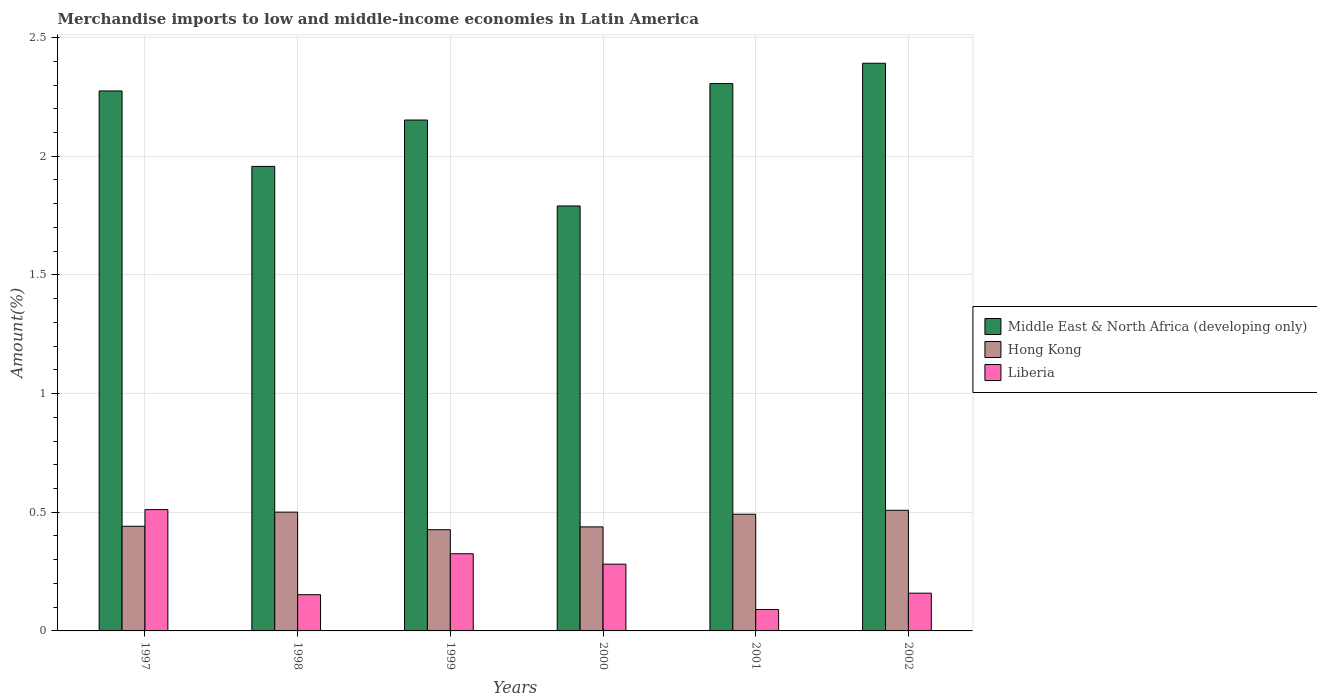Are the number of bars per tick equal to the number of legend labels?
Give a very brief answer. Yes. Are the number of bars on each tick of the X-axis equal?
Your response must be concise. Yes. How many bars are there on the 5th tick from the left?
Give a very brief answer. 3. How many bars are there on the 1st tick from the right?
Offer a terse response. 3. What is the percentage of amount earned from merchandise imports in Liberia in 2001?
Your response must be concise. 0.09. Across all years, what is the maximum percentage of amount earned from merchandise imports in Liberia?
Keep it short and to the point. 0.51. Across all years, what is the minimum percentage of amount earned from merchandise imports in Middle East & North Africa (developing only)?
Keep it short and to the point. 1.79. What is the total percentage of amount earned from merchandise imports in Middle East & North Africa (developing only) in the graph?
Offer a very short reply. 12.87. What is the difference between the percentage of amount earned from merchandise imports in Hong Kong in 2000 and that in 2001?
Your answer should be very brief. -0.05. What is the difference between the percentage of amount earned from merchandise imports in Middle East & North Africa (developing only) in 2002 and the percentage of amount earned from merchandise imports in Liberia in 1999?
Make the answer very short. 2.07. What is the average percentage of amount earned from merchandise imports in Liberia per year?
Offer a terse response. 0.25. In the year 2000, what is the difference between the percentage of amount earned from merchandise imports in Liberia and percentage of amount earned from merchandise imports in Middle East & North Africa (developing only)?
Give a very brief answer. -1.51. What is the ratio of the percentage of amount earned from merchandise imports in Hong Kong in 1997 to that in 1999?
Provide a short and direct response. 1.03. Is the percentage of amount earned from merchandise imports in Hong Kong in 1998 less than that in 2002?
Offer a terse response. Yes. What is the difference between the highest and the second highest percentage of amount earned from merchandise imports in Hong Kong?
Offer a terse response. 0.01. What is the difference between the highest and the lowest percentage of amount earned from merchandise imports in Middle East & North Africa (developing only)?
Your answer should be compact. 0.6. What does the 2nd bar from the left in 2001 represents?
Your response must be concise. Hong Kong. What does the 2nd bar from the right in 1997 represents?
Your answer should be compact. Hong Kong. Is it the case that in every year, the sum of the percentage of amount earned from merchandise imports in Middle East & North Africa (developing only) and percentage of amount earned from merchandise imports in Hong Kong is greater than the percentage of amount earned from merchandise imports in Liberia?
Your answer should be very brief. Yes. How many bars are there?
Make the answer very short. 18. Does the graph contain grids?
Provide a short and direct response. Yes. Where does the legend appear in the graph?
Offer a very short reply. Center right. How many legend labels are there?
Give a very brief answer. 3. What is the title of the graph?
Give a very brief answer. Merchandise imports to low and middle-income economies in Latin America. Does "Liechtenstein" appear as one of the legend labels in the graph?
Offer a very short reply. No. What is the label or title of the Y-axis?
Your response must be concise. Amount(%). What is the Amount(%) of Middle East & North Africa (developing only) in 1997?
Provide a short and direct response. 2.28. What is the Amount(%) of Hong Kong in 1997?
Provide a short and direct response. 0.44. What is the Amount(%) of Liberia in 1997?
Keep it short and to the point. 0.51. What is the Amount(%) of Middle East & North Africa (developing only) in 1998?
Keep it short and to the point. 1.96. What is the Amount(%) of Hong Kong in 1998?
Your answer should be very brief. 0.5. What is the Amount(%) of Liberia in 1998?
Give a very brief answer. 0.15. What is the Amount(%) in Middle East & North Africa (developing only) in 1999?
Give a very brief answer. 2.15. What is the Amount(%) of Hong Kong in 1999?
Provide a succinct answer. 0.43. What is the Amount(%) in Liberia in 1999?
Give a very brief answer. 0.33. What is the Amount(%) in Middle East & North Africa (developing only) in 2000?
Your response must be concise. 1.79. What is the Amount(%) of Hong Kong in 2000?
Offer a terse response. 0.44. What is the Amount(%) in Liberia in 2000?
Give a very brief answer. 0.28. What is the Amount(%) in Middle East & North Africa (developing only) in 2001?
Offer a very short reply. 2.31. What is the Amount(%) in Hong Kong in 2001?
Keep it short and to the point. 0.49. What is the Amount(%) of Liberia in 2001?
Give a very brief answer. 0.09. What is the Amount(%) of Middle East & North Africa (developing only) in 2002?
Ensure brevity in your answer.  2.39. What is the Amount(%) in Hong Kong in 2002?
Provide a succinct answer. 0.51. What is the Amount(%) of Liberia in 2002?
Provide a succinct answer. 0.16. Across all years, what is the maximum Amount(%) of Middle East & North Africa (developing only)?
Your response must be concise. 2.39. Across all years, what is the maximum Amount(%) of Hong Kong?
Give a very brief answer. 0.51. Across all years, what is the maximum Amount(%) of Liberia?
Offer a very short reply. 0.51. Across all years, what is the minimum Amount(%) of Middle East & North Africa (developing only)?
Ensure brevity in your answer.  1.79. Across all years, what is the minimum Amount(%) of Hong Kong?
Your response must be concise. 0.43. Across all years, what is the minimum Amount(%) of Liberia?
Make the answer very short. 0.09. What is the total Amount(%) of Middle East & North Africa (developing only) in the graph?
Offer a very short reply. 12.87. What is the total Amount(%) of Hong Kong in the graph?
Your response must be concise. 2.81. What is the total Amount(%) of Liberia in the graph?
Ensure brevity in your answer.  1.52. What is the difference between the Amount(%) in Middle East & North Africa (developing only) in 1997 and that in 1998?
Your answer should be compact. 0.32. What is the difference between the Amount(%) of Hong Kong in 1997 and that in 1998?
Make the answer very short. -0.06. What is the difference between the Amount(%) of Liberia in 1997 and that in 1998?
Offer a terse response. 0.36. What is the difference between the Amount(%) in Middle East & North Africa (developing only) in 1997 and that in 1999?
Ensure brevity in your answer.  0.12. What is the difference between the Amount(%) of Hong Kong in 1997 and that in 1999?
Provide a succinct answer. 0.01. What is the difference between the Amount(%) in Liberia in 1997 and that in 1999?
Offer a very short reply. 0.19. What is the difference between the Amount(%) in Middle East & North Africa (developing only) in 1997 and that in 2000?
Offer a very short reply. 0.48. What is the difference between the Amount(%) of Hong Kong in 1997 and that in 2000?
Your answer should be compact. 0. What is the difference between the Amount(%) of Liberia in 1997 and that in 2000?
Your response must be concise. 0.23. What is the difference between the Amount(%) of Middle East & North Africa (developing only) in 1997 and that in 2001?
Keep it short and to the point. -0.03. What is the difference between the Amount(%) in Hong Kong in 1997 and that in 2001?
Offer a very short reply. -0.05. What is the difference between the Amount(%) in Liberia in 1997 and that in 2001?
Your answer should be very brief. 0.42. What is the difference between the Amount(%) in Middle East & North Africa (developing only) in 1997 and that in 2002?
Your response must be concise. -0.12. What is the difference between the Amount(%) of Hong Kong in 1997 and that in 2002?
Your answer should be compact. -0.07. What is the difference between the Amount(%) in Liberia in 1997 and that in 2002?
Give a very brief answer. 0.35. What is the difference between the Amount(%) of Middle East & North Africa (developing only) in 1998 and that in 1999?
Give a very brief answer. -0.2. What is the difference between the Amount(%) in Hong Kong in 1998 and that in 1999?
Give a very brief answer. 0.07. What is the difference between the Amount(%) of Liberia in 1998 and that in 1999?
Make the answer very short. -0.17. What is the difference between the Amount(%) in Middle East & North Africa (developing only) in 1998 and that in 2000?
Your answer should be very brief. 0.17. What is the difference between the Amount(%) in Hong Kong in 1998 and that in 2000?
Your answer should be very brief. 0.06. What is the difference between the Amount(%) of Liberia in 1998 and that in 2000?
Your answer should be compact. -0.13. What is the difference between the Amount(%) of Middle East & North Africa (developing only) in 1998 and that in 2001?
Offer a terse response. -0.35. What is the difference between the Amount(%) of Hong Kong in 1998 and that in 2001?
Give a very brief answer. 0.01. What is the difference between the Amount(%) of Liberia in 1998 and that in 2001?
Keep it short and to the point. 0.06. What is the difference between the Amount(%) in Middle East & North Africa (developing only) in 1998 and that in 2002?
Offer a terse response. -0.43. What is the difference between the Amount(%) of Hong Kong in 1998 and that in 2002?
Make the answer very short. -0.01. What is the difference between the Amount(%) of Liberia in 1998 and that in 2002?
Make the answer very short. -0.01. What is the difference between the Amount(%) in Middle East & North Africa (developing only) in 1999 and that in 2000?
Provide a succinct answer. 0.36. What is the difference between the Amount(%) of Hong Kong in 1999 and that in 2000?
Provide a short and direct response. -0.01. What is the difference between the Amount(%) of Liberia in 1999 and that in 2000?
Make the answer very short. 0.04. What is the difference between the Amount(%) of Middle East & North Africa (developing only) in 1999 and that in 2001?
Your answer should be compact. -0.15. What is the difference between the Amount(%) in Hong Kong in 1999 and that in 2001?
Make the answer very short. -0.07. What is the difference between the Amount(%) of Liberia in 1999 and that in 2001?
Keep it short and to the point. 0.23. What is the difference between the Amount(%) of Middle East & North Africa (developing only) in 1999 and that in 2002?
Your answer should be compact. -0.24. What is the difference between the Amount(%) of Hong Kong in 1999 and that in 2002?
Offer a terse response. -0.08. What is the difference between the Amount(%) of Liberia in 1999 and that in 2002?
Your response must be concise. 0.17. What is the difference between the Amount(%) of Middle East & North Africa (developing only) in 2000 and that in 2001?
Your answer should be very brief. -0.52. What is the difference between the Amount(%) in Hong Kong in 2000 and that in 2001?
Ensure brevity in your answer.  -0.05. What is the difference between the Amount(%) in Liberia in 2000 and that in 2001?
Your response must be concise. 0.19. What is the difference between the Amount(%) in Middle East & North Africa (developing only) in 2000 and that in 2002?
Your response must be concise. -0.6. What is the difference between the Amount(%) of Hong Kong in 2000 and that in 2002?
Offer a terse response. -0.07. What is the difference between the Amount(%) of Liberia in 2000 and that in 2002?
Keep it short and to the point. 0.12. What is the difference between the Amount(%) of Middle East & North Africa (developing only) in 2001 and that in 2002?
Provide a succinct answer. -0.09. What is the difference between the Amount(%) in Hong Kong in 2001 and that in 2002?
Make the answer very short. -0.02. What is the difference between the Amount(%) of Liberia in 2001 and that in 2002?
Keep it short and to the point. -0.07. What is the difference between the Amount(%) of Middle East & North Africa (developing only) in 1997 and the Amount(%) of Hong Kong in 1998?
Provide a short and direct response. 1.77. What is the difference between the Amount(%) in Middle East & North Africa (developing only) in 1997 and the Amount(%) in Liberia in 1998?
Ensure brevity in your answer.  2.12. What is the difference between the Amount(%) in Hong Kong in 1997 and the Amount(%) in Liberia in 1998?
Offer a terse response. 0.29. What is the difference between the Amount(%) in Middle East & North Africa (developing only) in 1997 and the Amount(%) in Hong Kong in 1999?
Provide a succinct answer. 1.85. What is the difference between the Amount(%) of Middle East & North Africa (developing only) in 1997 and the Amount(%) of Liberia in 1999?
Your answer should be very brief. 1.95. What is the difference between the Amount(%) in Hong Kong in 1997 and the Amount(%) in Liberia in 1999?
Provide a succinct answer. 0.12. What is the difference between the Amount(%) of Middle East & North Africa (developing only) in 1997 and the Amount(%) of Hong Kong in 2000?
Keep it short and to the point. 1.84. What is the difference between the Amount(%) of Middle East & North Africa (developing only) in 1997 and the Amount(%) of Liberia in 2000?
Keep it short and to the point. 1.99. What is the difference between the Amount(%) in Hong Kong in 1997 and the Amount(%) in Liberia in 2000?
Offer a terse response. 0.16. What is the difference between the Amount(%) in Middle East & North Africa (developing only) in 1997 and the Amount(%) in Hong Kong in 2001?
Your response must be concise. 1.78. What is the difference between the Amount(%) in Middle East & North Africa (developing only) in 1997 and the Amount(%) in Liberia in 2001?
Offer a terse response. 2.18. What is the difference between the Amount(%) of Hong Kong in 1997 and the Amount(%) of Liberia in 2001?
Provide a short and direct response. 0.35. What is the difference between the Amount(%) of Middle East & North Africa (developing only) in 1997 and the Amount(%) of Hong Kong in 2002?
Offer a terse response. 1.77. What is the difference between the Amount(%) in Middle East & North Africa (developing only) in 1997 and the Amount(%) in Liberia in 2002?
Offer a terse response. 2.12. What is the difference between the Amount(%) in Hong Kong in 1997 and the Amount(%) in Liberia in 2002?
Make the answer very short. 0.28. What is the difference between the Amount(%) of Middle East & North Africa (developing only) in 1998 and the Amount(%) of Hong Kong in 1999?
Offer a very short reply. 1.53. What is the difference between the Amount(%) of Middle East & North Africa (developing only) in 1998 and the Amount(%) of Liberia in 1999?
Offer a very short reply. 1.63. What is the difference between the Amount(%) of Hong Kong in 1998 and the Amount(%) of Liberia in 1999?
Your answer should be very brief. 0.18. What is the difference between the Amount(%) of Middle East & North Africa (developing only) in 1998 and the Amount(%) of Hong Kong in 2000?
Your answer should be compact. 1.52. What is the difference between the Amount(%) in Middle East & North Africa (developing only) in 1998 and the Amount(%) in Liberia in 2000?
Provide a succinct answer. 1.68. What is the difference between the Amount(%) in Hong Kong in 1998 and the Amount(%) in Liberia in 2000?
Your response must be concise. 0.22. What is the difference between the Amount(%) in Middle East & North Africa (developing only) in 1998 and the Amount(%) in Hong Kong in 2001?
Provide a short and direct response. 1.47. What is the difference between the Amount(%) of Middle East & North Africa (developing only) in 1998 and the Amount(%) of Liberia in 2001?
Your response must be concise. 1.87. What is the difference between the Amount(%) of Hong Kong in 1998 and the Amount(%) of Liberia in 2001?
Offer a very short reply. 0.41. What is the difference between the Amount(%) in Middle East & North Africa (developing only) in 1998 and the Amount(%) in Hong Kong in 2002?
Give a very brief answer. 1.45. What is the difference between the Amount(%) of Middle East & North Africa (developing only) in 1998 and the Amount(%) of Liberia in 2002?
Ensure brevity in your answer.  1.8. What is the difference between the Amount(%) of Hong Kong in 1998 and the Amount(%) of Liberia in 2002?
Give a very brief answer. 0.34. What is the difference between the Amount(%) in Middle East & North Africa (developing only) in 1999 and the Amount(%) in Hong Kong in 2000?
Provide a succinct answer. 1.71. What is the difference between the Amount(%) of Middle East & North Africa (developing only) in 1999 and the Amount(%) of Liberia in 2000?
Your response must be concise. 1.87. What is the difference between the Amount(%) in Hong Kong in 1999 and the Amount(%) in Liberia in 2000?
Offer a very short reply. 0.15. What is the difference between the Amount(%) in Middle East & North Africa (developing only) in 1999 and the Amount(%) in Hong Kong in 2001?
Your answer should be very brief. 1.66. What is the difference between the Amount(%) of Middle East & North Africa (developing only) in 1999 and the Amount(%) of Liberia in 2001?
Your response must be concise. 2.06. What is the difference between the Amount(%) of Hong Kong in 1999 and the Amount(%) of Liberia in 2001?
Your answer should be very brief. 0.34. What is the difference between the Amount(%) of Middle East & North Africa (developing only) in 1999 and the Amount(%) of Hong Kong in 2002?
Make the answer very short. 1.64. What is the difference between the Amount(%) of Middle East & North Africa (developing only) in 1999 and the Amount(%) of Liberia in 2002?
Your response must be concise. 1.99. What is the difference between the Amount(%) in Hong Kong in 1999 and the Amount(%) in Liberia in 2002?
Your answer should be very brief. 0.27. What is the difference between the Amount(%) in Middle East & North Africa (developing only) in 2000 and the Amount(%) in Hong Kong in 2001?
Keep it short and to the point. 1.3. What is the difference between the Amount(%) in Middle East & North Africa (developing only) in 2000 and the Amount(%) in Liberia in 2001?
Give a very brief answer. 1.7. What is the difference between the Amount(%) in Hong Kong in 2000 and the Amount(%) in Liberia in 2001?
Offer a very short reply. 0.35. What is the difference between the Amount(%) in Middle East & North Africa (developing only) in 2000 and the Amount(%) in Hong Kong in 2002?
Offer a very short reply. 1.28. What is the difference between the Amount(%) in Middle East & North Africa (developing only) in 2000 and the Amount(%) in Liberia in 2002?
Offer a very short reply. 1.63. What is the difference between the Amount(%) of Hong Kong in 2000 and the Amount(%) of Liberia in 2002?
Provide a short and direct response. 0.28. What is the difference between the Amount(%) of Middle East & North Africa (developing only) in 2001 and the Amount(%) of Hong Kong in 2002?
Ensure brevity in your answer.  1.8. What is the difference between the Amount(%) in Middle East & North Africa (developing only) in 2001 and the Amount(%) in Liberia in 2002?
Your answer should be very brief. 2.15. What is the difference between the Amount(%) in Hong Kong in 2001 and the Amount(%) in Liberia in 2002?
Keep it short and to the point. 0.33. What is the average Amount(%) of Middle East & North Africa (developing only) per year?
Your answer should be compact. 2.15. What is the average Amount(%) in Hong Kong per year?
Keep it short and to the point. 0.47. What is the average Amount(%) in Liberia per year?
Give a very brief answer. 0.25. In the year 1997, what is the difference between the Amount(%) in Middle East & North Africa (developing only) and Amount(%) in Hong Kong?
Your response must be concise. 1.83. In the year 1997, what is the difference between the Amount(%) in Middle East & North Africa (developing only) and Amount(%) in Liberia?
Keep it short and to the point. 1.76. In the year 1997, what is the difference between the Amount(%) of Hong Kong and Amount(%) of Liberia?
Make the answer very short. -0.07. In the year 1998, what is the difference between the Amount(%) in Middle East & North Africa (developing only) and Amount(%) in Hong Kong?
Make the answer very short. 1.46. In the year 1998, what is the difference between the Amount(%) in Middle East & North Africa (developing only) and Amount(%) in Liberia?
Give a very brief answer. 1.8. In the year 1998, what is the difference between the Amount(%) of Hong Kong and Amount(%) of Liberia?
Provide a succinct answer. 0.35. In the year 1999, what is the difference between the Amount(%) of Middle East & North Africa (developing only) and Amount(%) of Hong Kong?
Offer a very short reply. 1.73. In the year 1999, what is the difference between the Amount(%) in Middle East & North Africa (developing only) and Amount(%) in Liberia?
Give a very brief answer. 1.83. In the year 1999, what is the difference between the Amount(%) of Hong Kong and Amount(%) of Liberia?
Offer a terse response. 0.1. In the year 2000, what is the difference between the Amount(%) in Middle East & North Africa (developing only) and Amount(%) in Hong Kong?
Ensure brevity in your answer.  1.35. In the year 2000, what is the difference between the Amount(%) of Middle East & North Africa (developing only) and Amount(%) of Liberia?
Offer a very short reply. 1.51. In the year 2000, what is the difference between the Amount(%) of Hong Kong and Amount(%) of Liberia?
Provide a short and direct response. 0.16. In the year 2001, what is the difference between the Amount(%) of Middle East & North Africa (developing only) and Amount(%) of Hong Kong?
Make the answer very short. 1.81. In the year 2001, what is the difference between the Amount(%) in Middle East & North Africa (developing only) and Amount(%) in Liberia?
Offer a terse response. 2.22. In the year 2001, what is the difference between the Amount(%) in Hong Kong and Amount(%) in Liberia?
Offer a terse response. 0.4. In the year 2002, what is the difference between the Amount(%) of Middle East & North Africa (developing only) and Amount(%) of Hong Kong?
Give a very brief answer. 1.88. In the year 2002, what is the difference between the Amount(%) in Middle East & North Africa (developing only) and Amount(%) in Liberia?
Make the answer very short. 2.23. In the year 2002, what is the difference between the Amount(%) in Hong Kong and Amount(%) in Liberia?
Give a very brief answer. 0.35. What is the ratio of the Amount(%) of Middle East & North Africa (developing only) in 1997 to that in 1998?
Provide a short and direct response. 1.16. What is the ratio of the Amount(%) of Hong Kong in 1997 to that in 1998?
Offer a very short reply. 0.88. What is the ratio of the Amount(%) in Liberia in 1997 to that in 1998?
Offer a very short reply. 3.35. What is the ratio of the Amount(%) in Middle East & North Africa (developing only) in 1997 to that in 1999?
Your response must be concise. 1.06. What is the ratio of the Amount(%) in Hong Kong in 1997 to that in 1999?
Your response must be concise. 1.03. What is the ratio of the Amount(%) in Liberia in 1997 to that in 1999?
Make the answer very short. 1.57. What is the ratio of the Amount(%) of Middle East & North Africa (developing only) in 1997 to that in 2000?
Provide a short and direct response. 1.27. What is the ratio of the Amount(%) in Liberia in 1997 to that in 2000?
Your response must be concise. 1.82. What is the ratio of the Amount(%) in Middle East & North Africa (developing only) in 1997 to that in 2001?
Offer a terse response. 0.99. What is the ratio of the Amount(%) of Hong Kong in 1997 to that in 2001?
Make the answer very short. 0.9. What is the ratio of the Amount(%) in Liberia in 1997 to that in 2001?
Give a very brief answer. 5.66. What is the ratio of the Amount(%) of Middle East & North Africa (developing only) in 1997 to that in 2002?
Your response must be concise. 0.95. What is the ratio of the Amount(%) in Hong Kong in 1997 to that in 2002?
Offer a very short reply. 0.87. What is the ratio of the Amount(%) in Liberia in 1997 to that in 2002?
Your answer should be compact. 3.21. What is the ratio of the Amount(%) in Middle East & North Africa (developing only) in 1998 to that in 1999?
Ensure brevity in your answer.  0.91. What is the ratio of the Amount(%) in Hong Kong in 1998 to that in 1999?
Offer a very short reply. 1.17. What is the ratio of the Amount(%) of Liberia in 1998 to that in 1999?
Offer a terse response. 0.47. What is the ratio of the Amount(%) of Middle East & North Africa (developing only) in 1998 to that in 2000?
Keep it short and to the point. 1.09. What is the ratio of the Amount(%) in Hong Kong in 1998 to that in 2000?
Offer a terse response. 1.14. What is the ratio of the Amount(%) of Liberia in 1998 to that in 2000?
Your answer should be compact. 0.54. What is the ratio of the Amount(%) of Middle East & North Africa (developing only) in 1998 to that in 2001?
Ensure brevity in your answer.  0.85. What is the ratio of the Amount(%) in Hong Kong in 1998 to that in 2001?
Make the answer very short. 1.02. What is the ratio of the Amount(%) of Liberia in 1998 to that in 2001?
Provide a succinct answer. 1.69. What is the ratio of the Amount(%) of Middle East & North Africa (developing only) in 1998 to that in 2002?
Give a very brief answer. 0.82. What is the ratio of the Amount(%) of Hong Kong in 1998 to that in 2002?
Keep it short and to the point. 0.98. What is the ratio of the Amount(%) of Liberia in 1998 to that in 2002?
Give a very brief answer. 0.96. What is the ratio of the Amount(%) in Middle East & North Africa (developing only) in 1999 to that in 2000?
Provide a succinct answer. 1.2. What is the ratio of the Amount(%) of Hong Kong in 1999 to that in 2000?
Your response must be concise. 0.97. What is the ratio of the Amount(%) of Liberia in 1999 to that in 2000?
Offer a terse response. 1.16. What is the ratio of the Amount(%) of Middle East & North Africa (developing only) in 1999 to that in 2001?
Ensure brevity in your answer.  0.93. What is the ratio of the Amount(%) in Hong Kong in 1999 to that in 2001?
Provide a succinct answer. 0.87. What is the ratio of the Amount(%) of Liberia in 1999 to that in 2001?
Keep it short and to the point. 3.6. What is the ratio of the Amount(%) of Hong Kong in 1999 to that in 2002?
Provide a succinct answer. 0.84. What is the ratio of the Amount(%) in Liberia in 1999 to that in 2002?
Your answer should be very brief. 2.04. What is the ratio of the Amount(%) of Middle East & North Africa (developing only) in 2000 to that in 2001?
Provide a succinct answer. 0.78. What is the ratio of the Amount(%) in Hong Kong in 2000 to that in 2001?
Your answer should be compact. 0.89. What is the ratio of the Amount(%) of Liberia in 2000 to that in 2001?
Offer a very short reply. 3.12. What is the ratio of the Amount(%) of Middle East & North Africa (developing only) in 2000 to that in 2002?
Your answer should be very brief. 0.75. What is the ratio of the Amount(%) of Hong Kong in 2000 to that in 2002?
Your response must be concise. 0.86. What is the ratio of the Amount(%) in Liberia in 2000 to that in 2002?
Keep it short and to the point. 1.77. What is the ratio of the Amount(%) of Middle East & North Africa (developing only) in 2001 to that in 2002?
Give a very brief answer. 0.96. What is the ratio of the Amount(%) in Hong Kong in 2001 to that in 2002?
Give a very brief answer. 0.97. What is the ratio of the Amount(%) of Liberia in 2001 to that in 2002?
Ensure brevity in your answer.  0.57. What is the difference between the highest and the second highest Amount(%) of Middle East & North Africa (developing only)?
Provide a succinct answer. 0.09. What is the difference between the highest and the second highest Amount(%) in Hong Kong?
Keep it short and to the point. 0.01. What is the difference between the highest and the second highest Amount(%) of Liberia?
Ensure brevity in your answer.  0.19. What is the difference between the highest and the lowest Amount(%) of Middle East & North Africa (developing only)?
Provide a succinct answer. 0.6. What is the difference between the highest and the lowest Amount(%) in Hong Kong?
Offer a very short reply. 0.08. What is the difference between the highest and the lowest Amount(%) of Liberia?
Give a very brief answer. 0.42. 